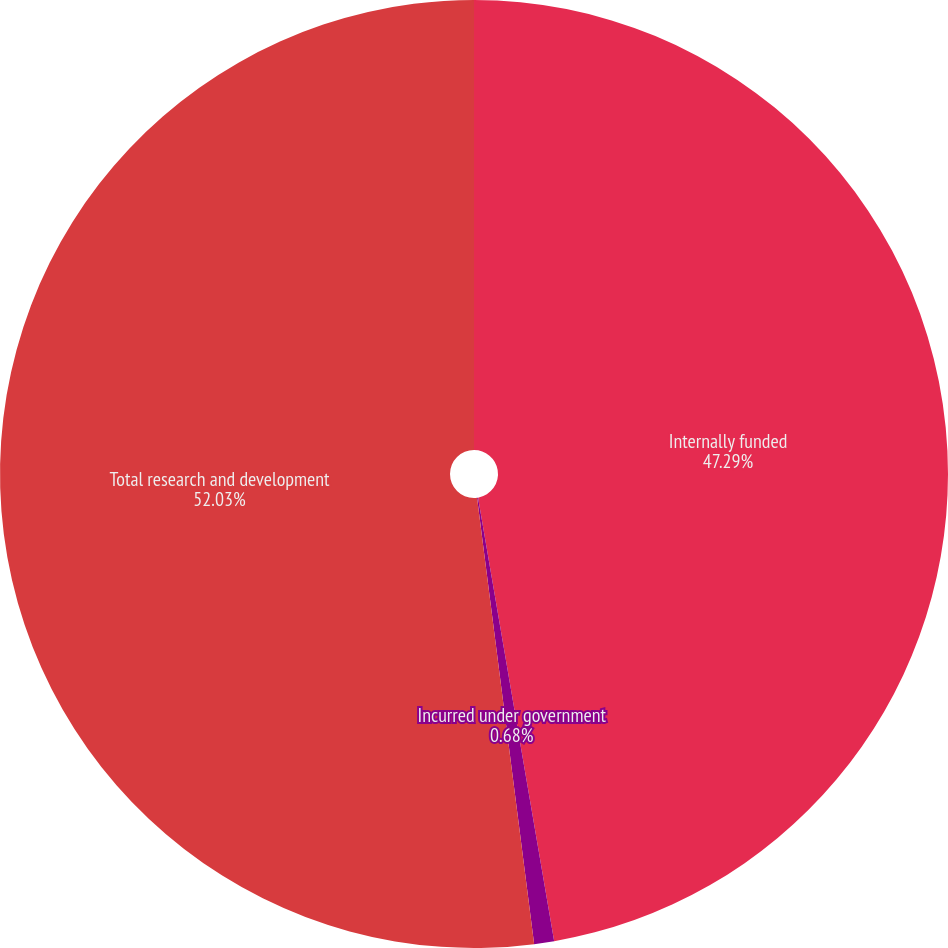<chart> <loc_0><loc_0><loc_500><loc_500><pie_chart><fcel>Internally funded<fcel>Incurred under government<fcel>Total research and development<nl><fcel>47.29%<fcel>0.68%<fcel>52.02%<nl></chart> 